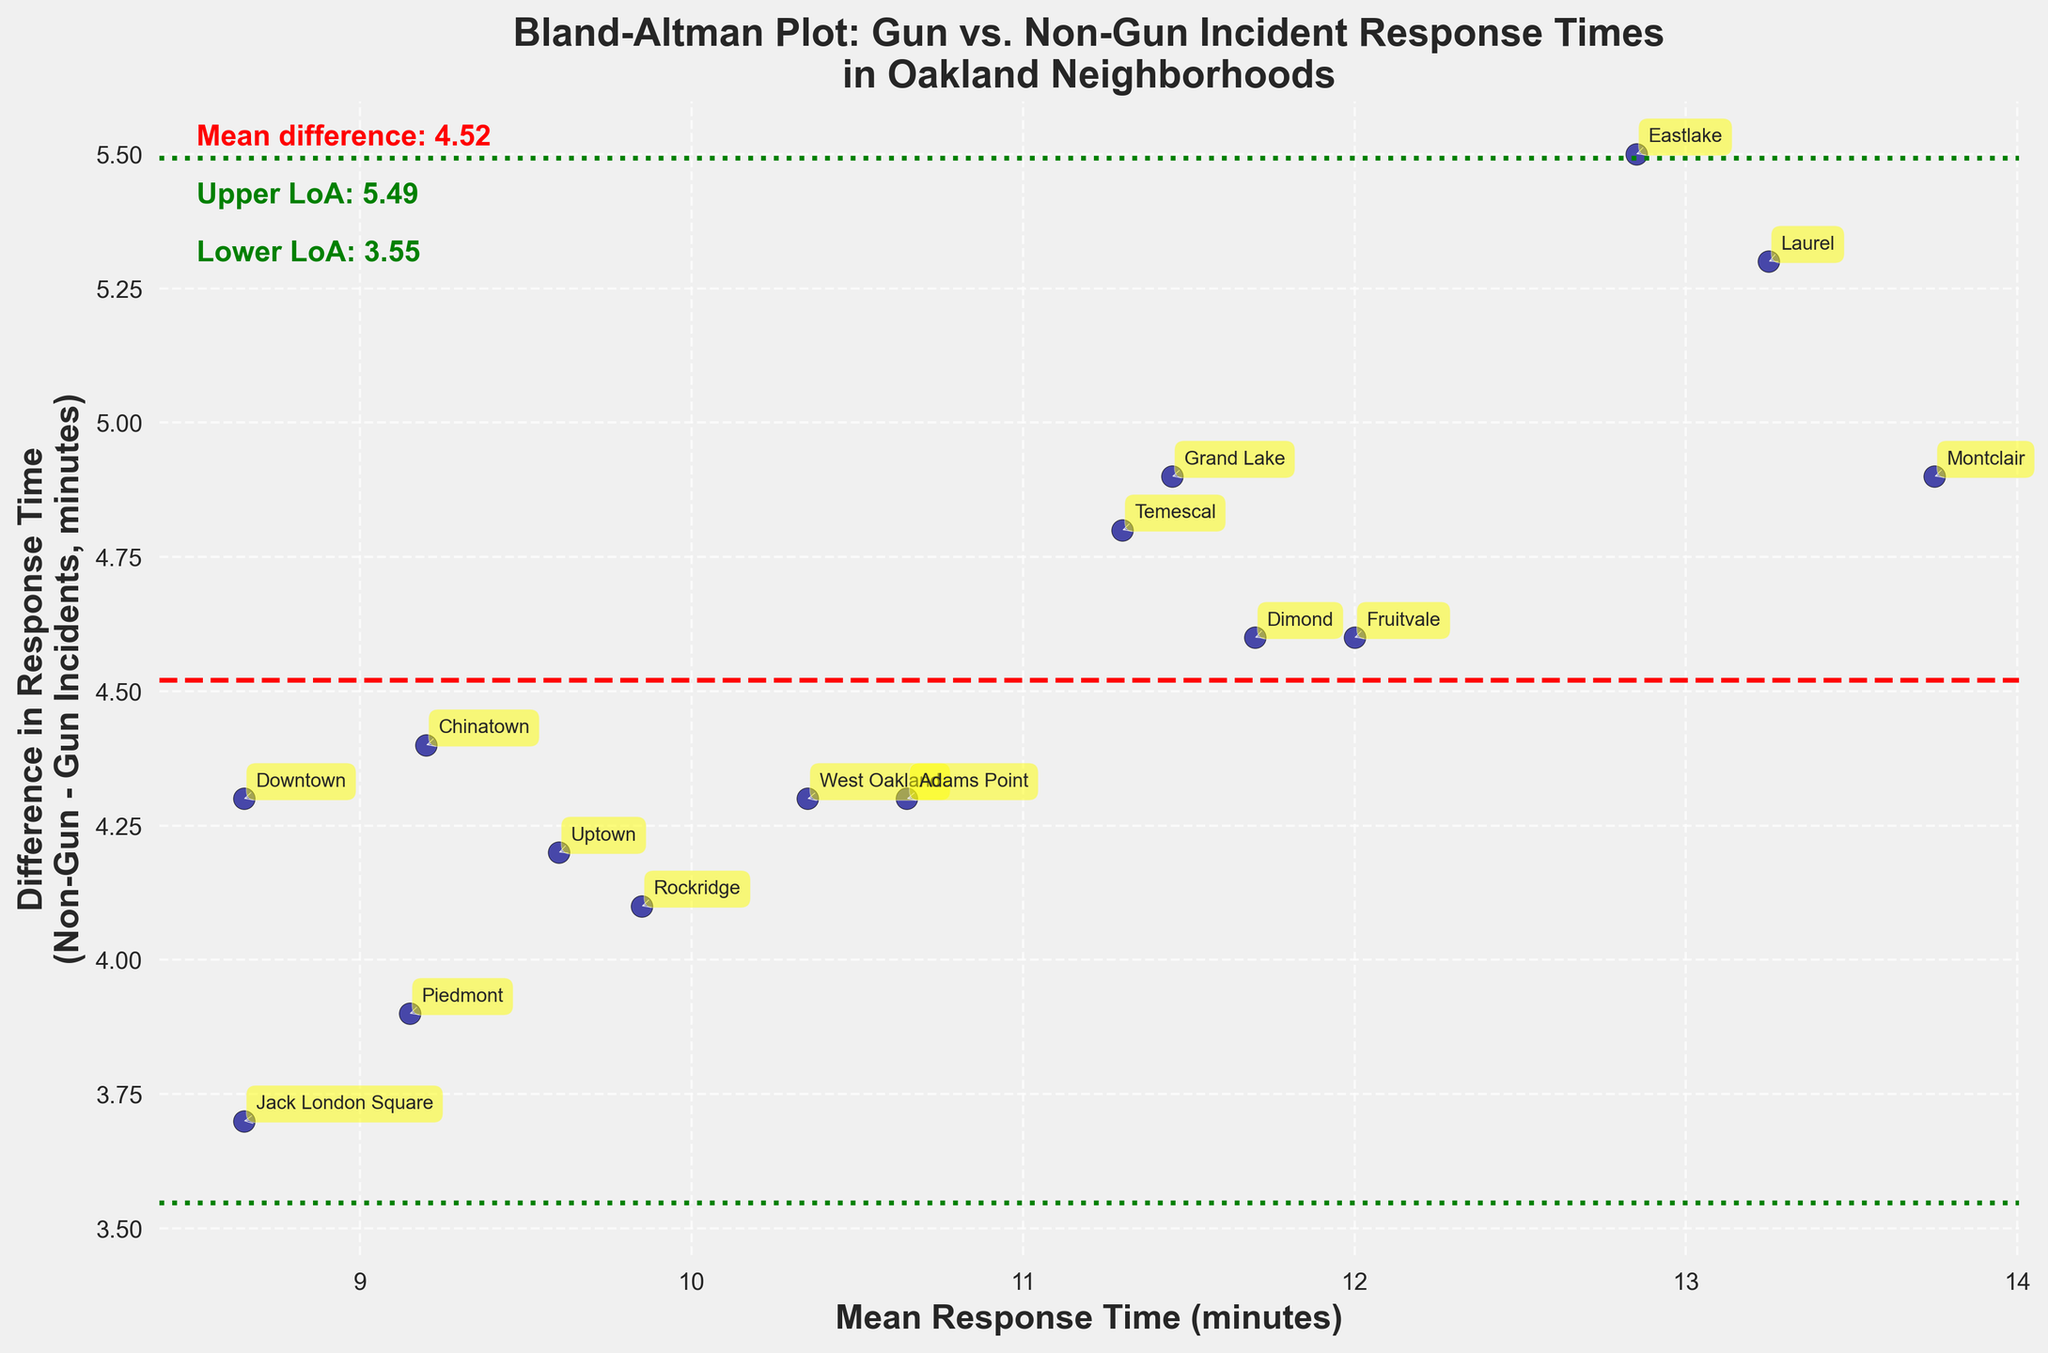What is the title of the plot? The title of the plot is located at the top and provides an overall description of what the data represents.
Answer: Bland-Altman Plot: Gun vs. Non-Gun Incident Response Times in Oakland Neighborhoods What do the red and green lines represent? The red line represents the mean difference in response times between non-gun and gun-related incidents. The green lines represent the upper and lower limits of agreement (LoA), which are calculated as mean difference ± 1.96 times the standard deviation of the differences.
Answer: Mean difference (red); Limits of Agreement (green) How many neighborhoods are represented in the plot? Each data point in the plot represents a neighborhood. By counting the points and their labels, we can determine the total number of neighborhoods represented.
Answer: 15 Which neighborhood has the largest difference in response time between gun-related and non-gun-related incidents? By identifying the data point with the highest vertical distance from the mean difference line, we can find the neighborhood with the largest response time difference.
Answer: Montclair What is the approximate mean difference in response times? The mean difference is indicated by the red line, and the exact value is displayed in the text on the plot.
Answer: 4.57 minutes Which neighborhood has the smallest mean response time for incidents? To find this, look for the data point corresponding to the lowest value on the x-axis (mean of gun and non-gun response times).
Answer: Jack London Square Is there any neighborhood where the response time to gun-related incidents is almost the same as to non-gun-related incidents? This can be observed by identifying points close to the zero difference line on the y-axis.
Answer: Uptown What inference can be drawn if most points lie between the green lines? If most points lie between the limits of agreement (green lines), it suggests that the response times for gun and non-gun incidents are generally consistent and within an expected range of variability.
Answer: Consistent response times What does the scatter plot indicate about the variability of response times in different neighborhoods? The spread of points on the plot along the y-axis indicates the variability in the differences of response times between gun and non-gun incidents. Wider spread shows higher variability.
Answer: High variability in response times Which neighborhoods fall outside the limits of agreement, indicating unusually high or low differences in response times? Points outside the green lines indicate neighborhoods with response times that differ significantly from the average mean difference ± 1.96 times the standard deviation. Identify these neighborhoods by their annotations outside the green boundaries.
Answer: Montclair, Piedmont 